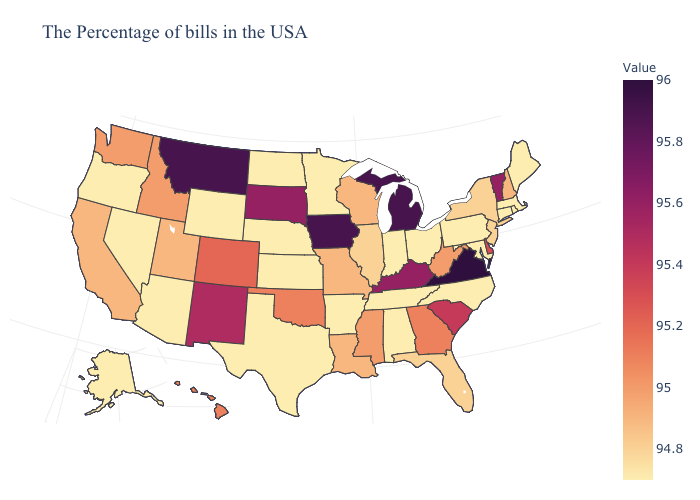Among the states that border Louisiana , does Arkansas have the highest value?
Quick response, please. No. Does Pennsylvania have the highest value in the USA?
Answer briefly. No. Does Iowa have the highest value in the MidWest?
Quick response, please. Yes. Does the map have missing data?
Quick response, please. No. 